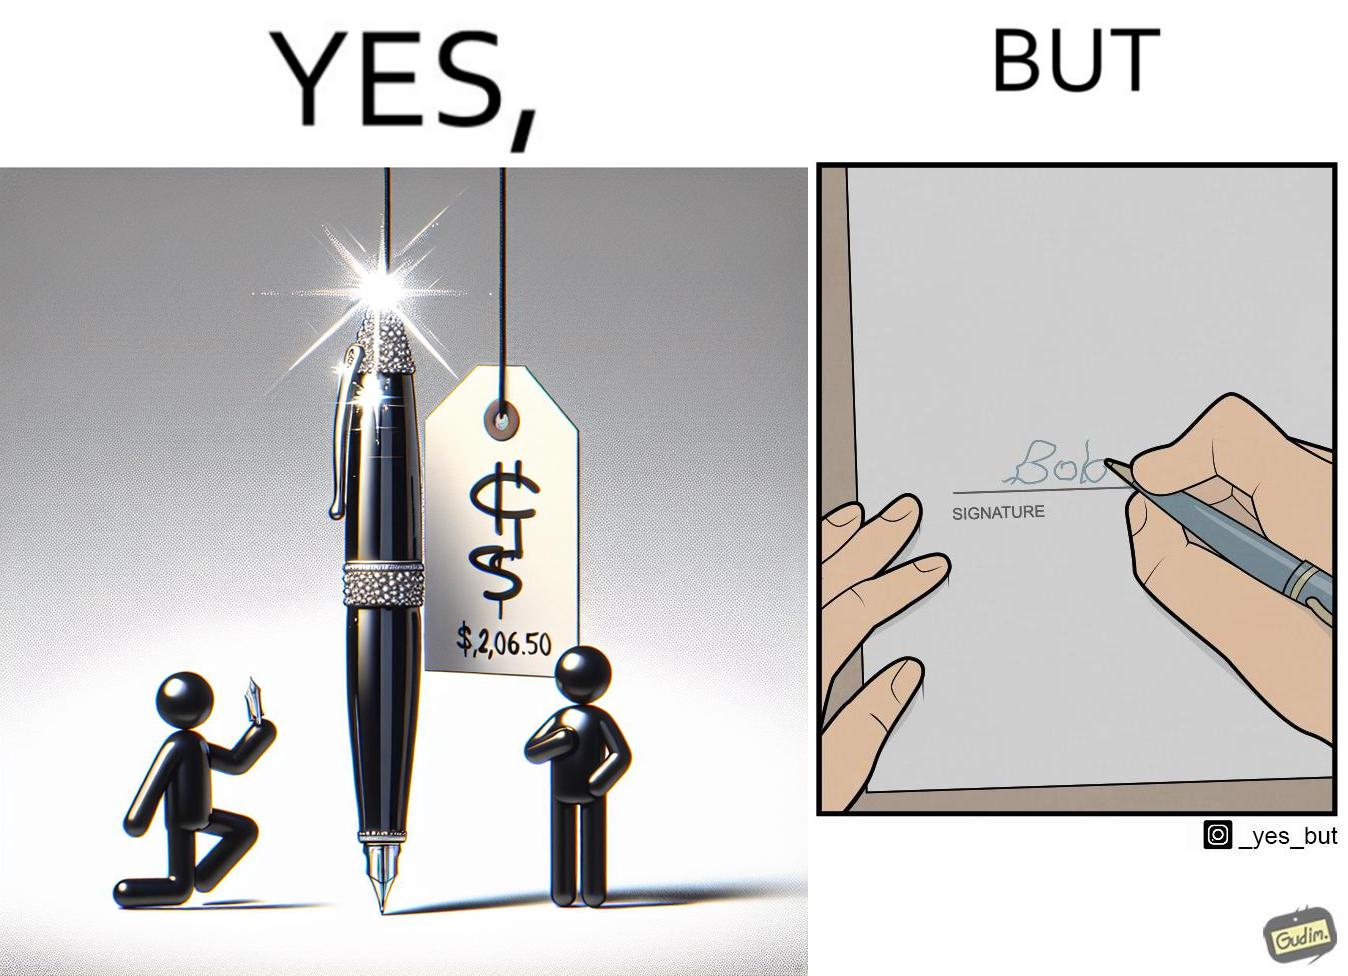Provide a description of this image. The image is ironic, because it conveys the message that even with the costliest of pens people handwriting remains the same 